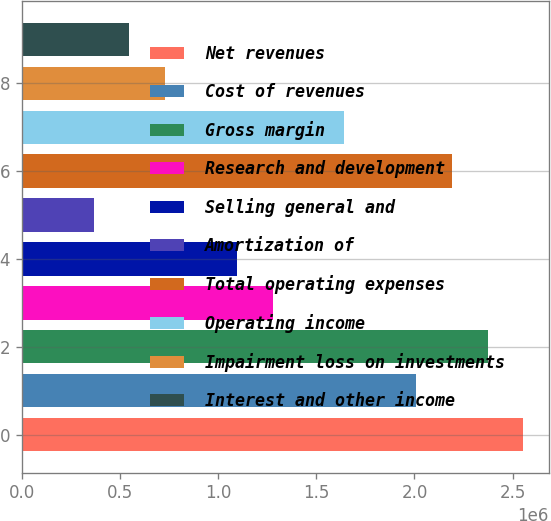Convert chart to OTSL. <chart><loc_0><loc_0><loc_500><loc_500><bar_chart><fcel>Net revenues<fcel>Cost of revenues<fcel>Gross margin<fcel>Research and development<fcel>Selling general and<fcel>Amortization of<fcel>Total operating expenses<fcel>Operating income<fcel>Impairment loss on investments<fcel>Interest and other income<nl><fcel>2.55526e+06<fcel>2.0077e+06<fcel>2.37274e+06<fcel>1.27763e+06<fcel>1.09511e+06<fcel>365038<fcel>2.19022e+06<fcel>1.64267e+06<fcel>730074<fcel>547556<nl></chart> 